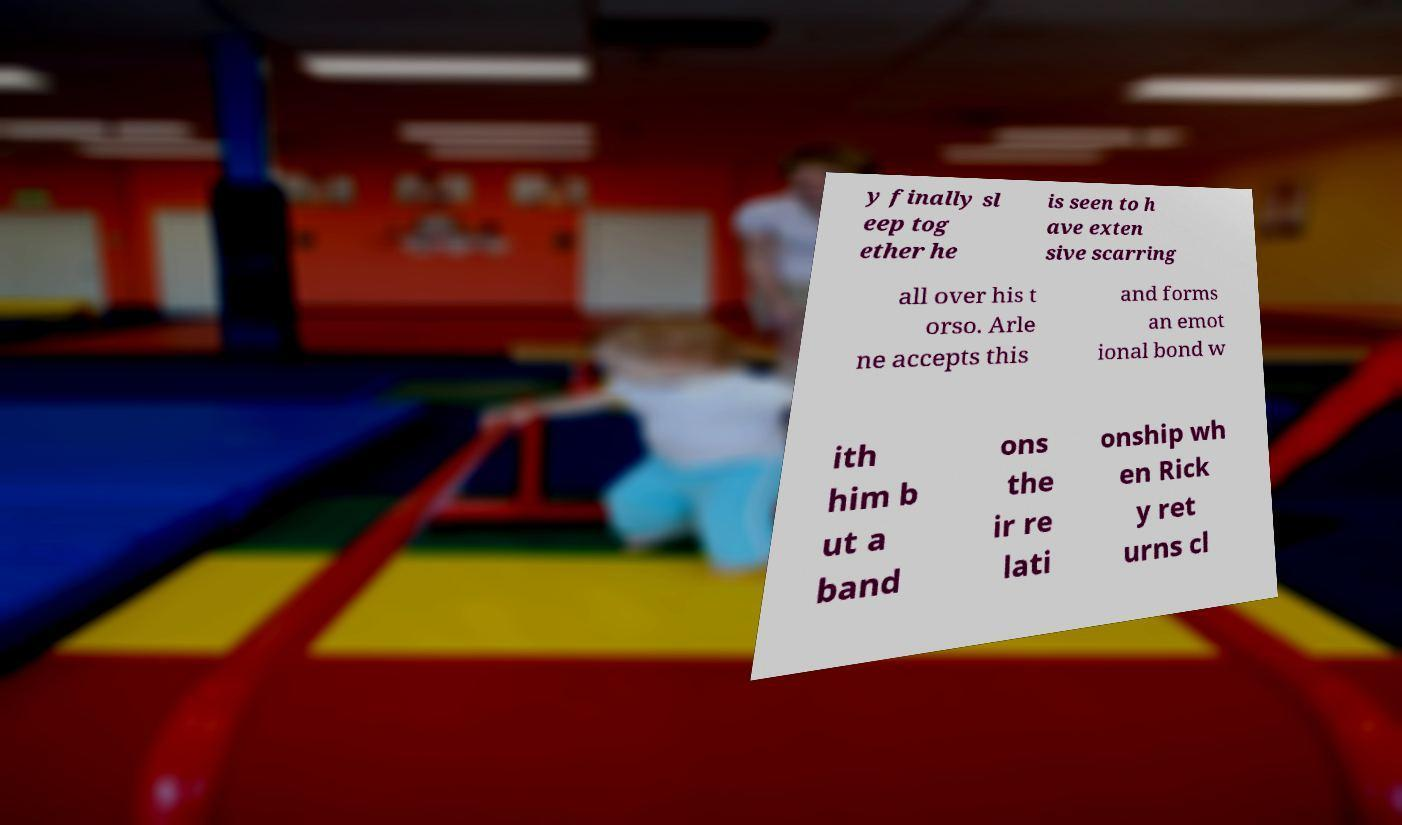For documentation purposes, I need the text within this image transcribed. Could you provide that? y finally sl eep tog ether he is seen to h ave exten sive scarring all over his t orso. Arle ne accepts this and forms an emot ional bond w ith him b ut a band ons the ir re lati onship wh en Rick y ret urns cl 